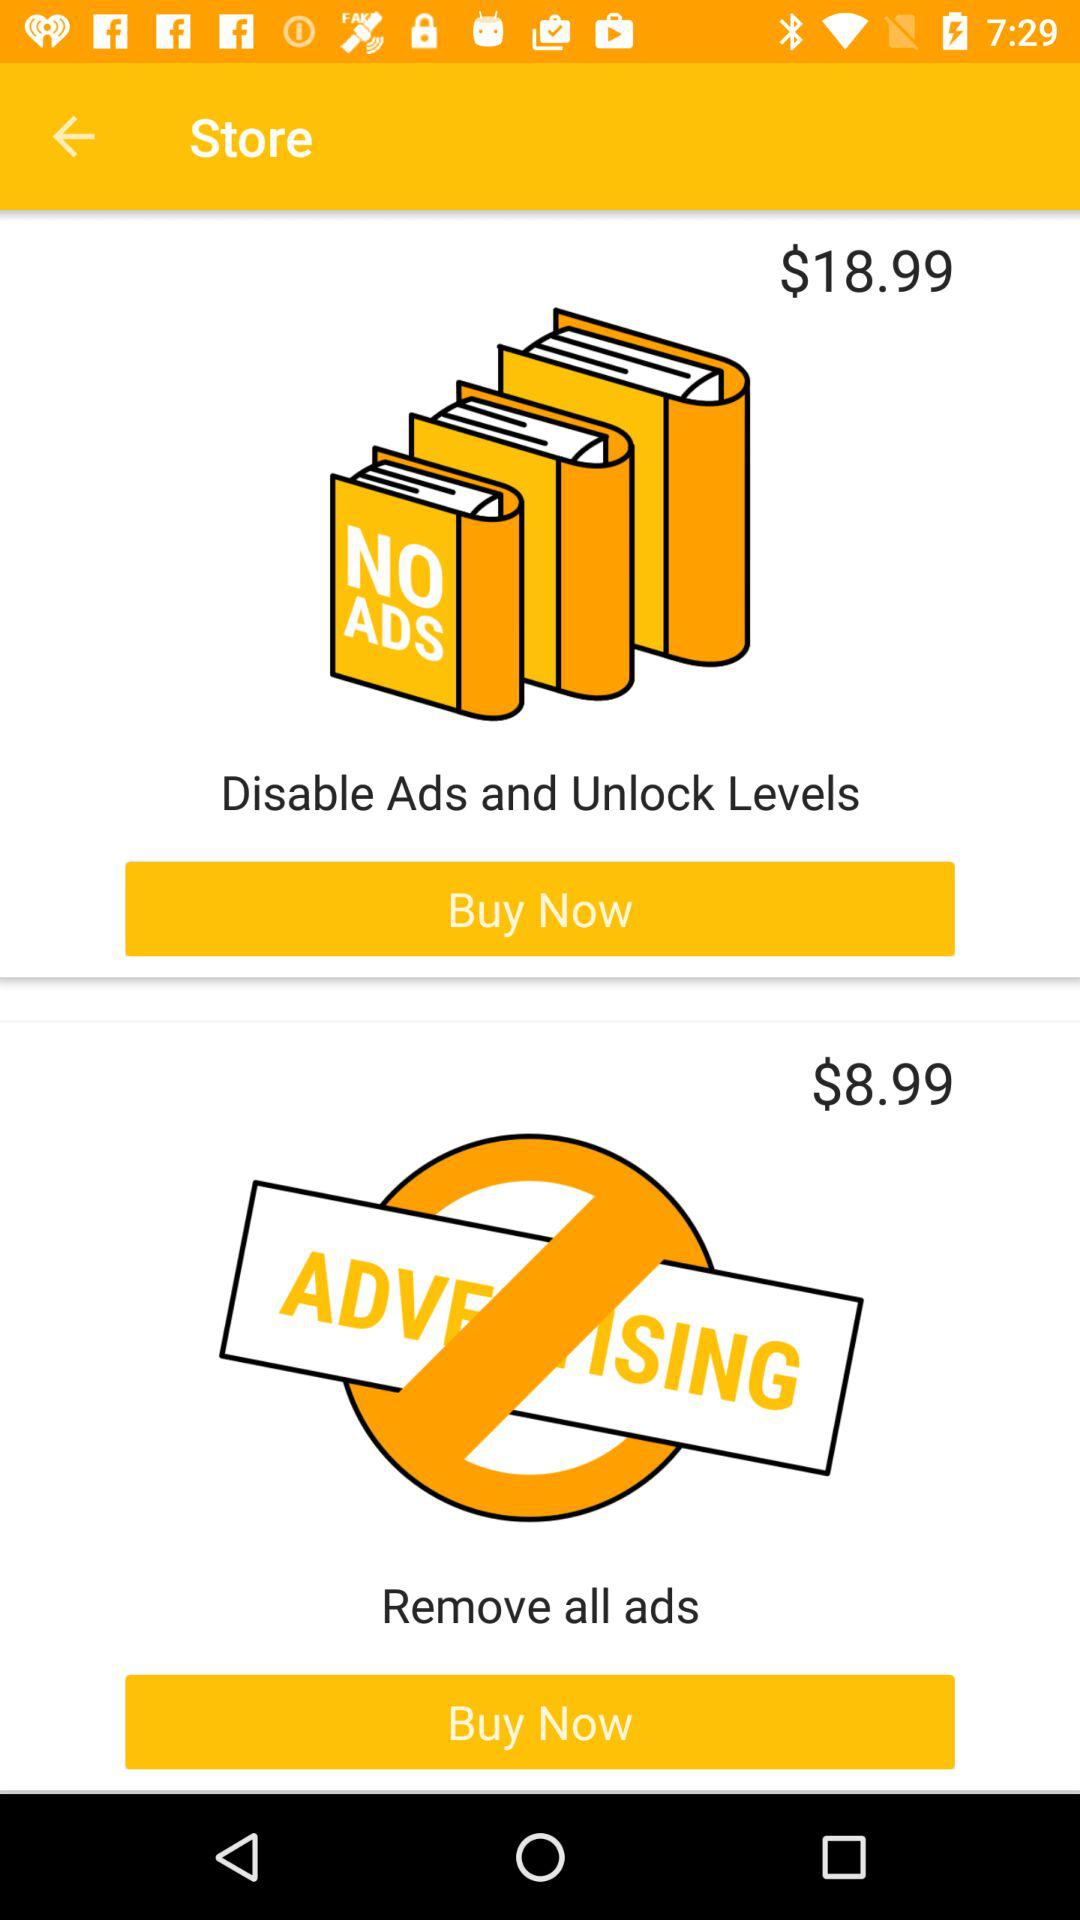What is the price of "Remove all ads"? The price is $8.99. 